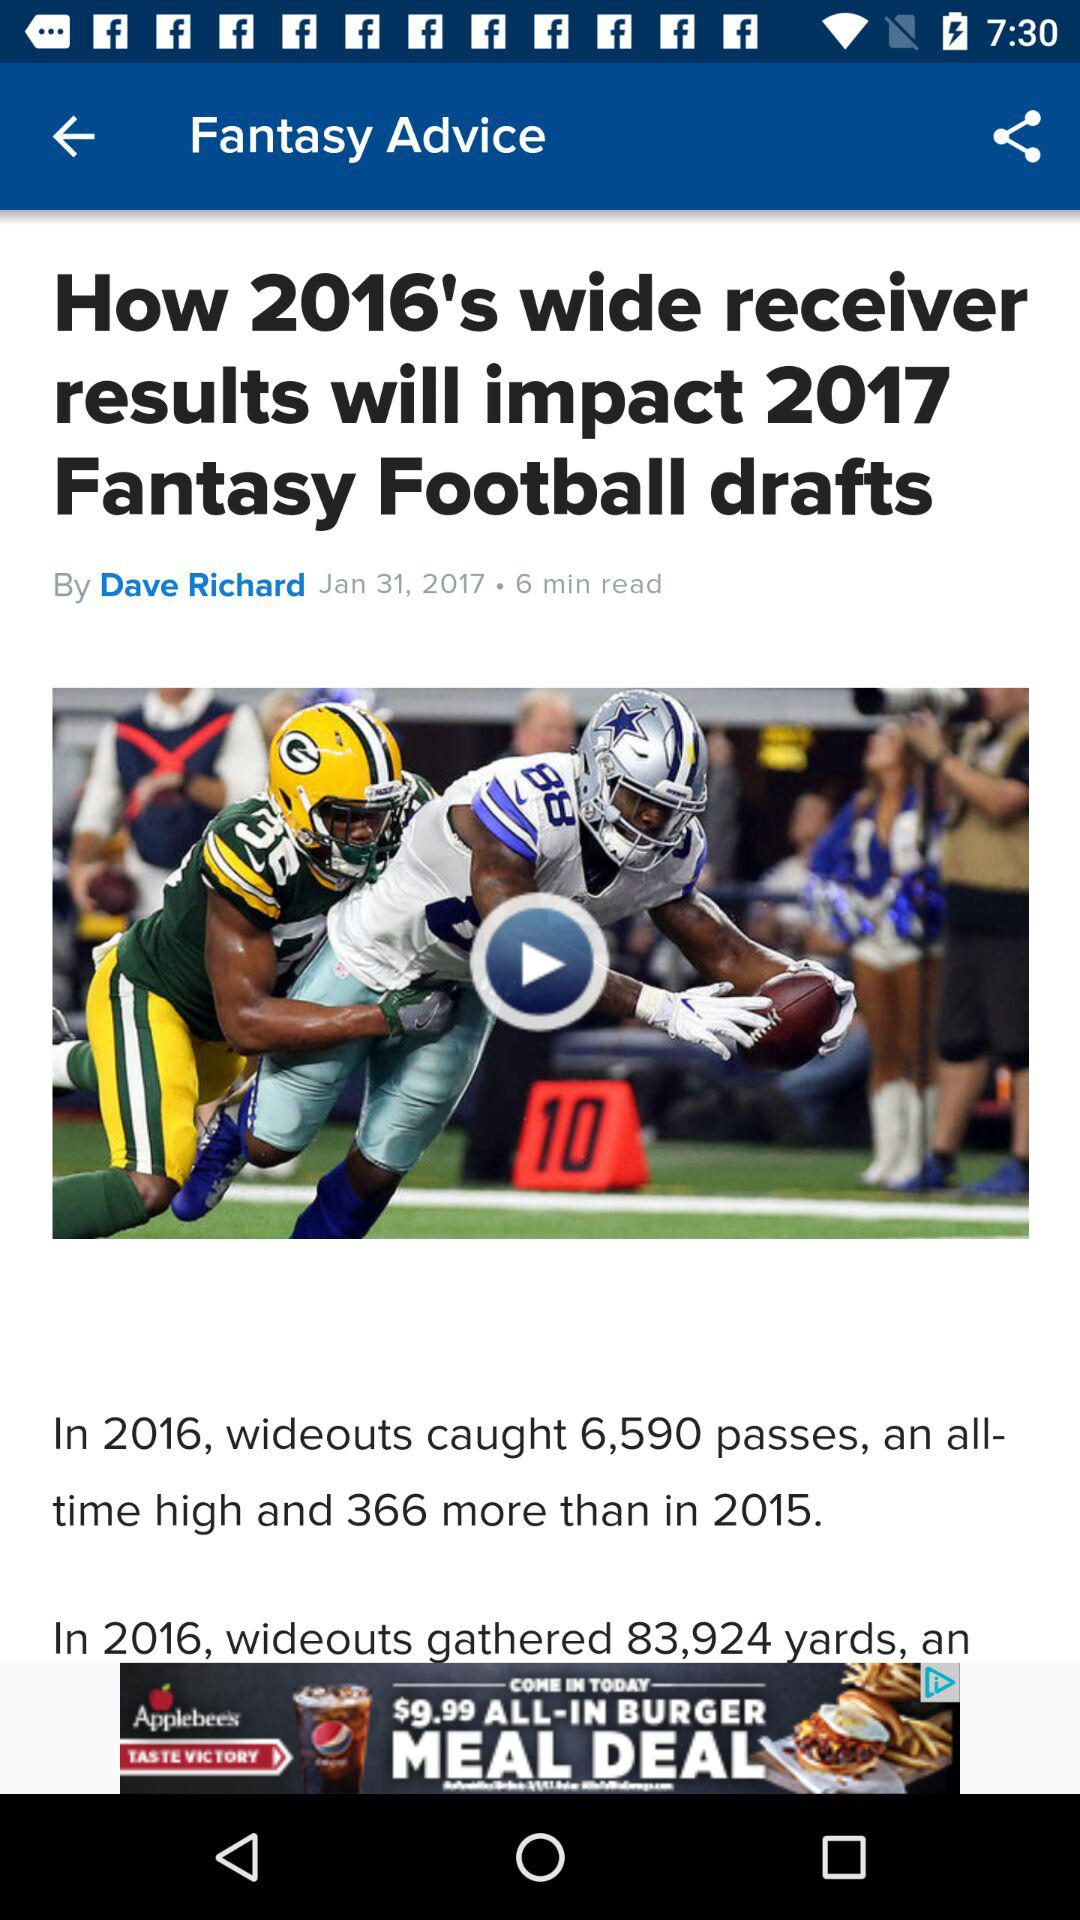Who gave the advice?
When the provided information is insufficient, respond with <no answer>. <no answer> 